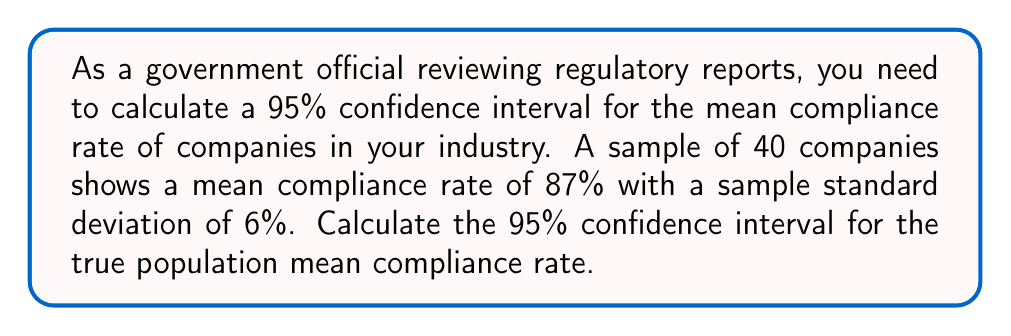Can you answer this question? To calculate the confidence interval, we'll follow these steps:

1. Identify the known values:
   - Sample size: $n = 40$
   - Sample mean: $\bar{x} = 87\%$
   - Sample standard deviation: $s = 6\%$
   - Confidence level: 95% (α = 0.05)

2. Find the critical value ($t$-value) for a 95% confidence interval with 39 degrees of freedom:
   $t_{0.025, 39} = 2.023$ (from t-distribution table)

3. Calculate the margin of error:
   $\text{Margin of Error} = t_{0.025, 39} \cdot \frac{s}{\sqrt{n}}$
   $= 2.023 \cdot \frac{6\%}{\sqrt{40}}$
   $= 2.023 \cdot \frac{6\%}{6.325}$
   $= 2.023 \cdot 0.949\%$
   $= 1.92\%$

4. Calculate the confidence interval:
   Lower bound: $\bar{x} - \text{Margin of Error} = 87\% - 1.92\% = 85.08\%$
   Upper bound: $\bar{x} + \text{Margin of Error} = 87\% + 1.92\% = 88.92\%$

Therefore, the 95% confidence interval for the true population mean compliance rate is (85.08%, 88.92%).
Answer: (85.08%, 88.92%) 